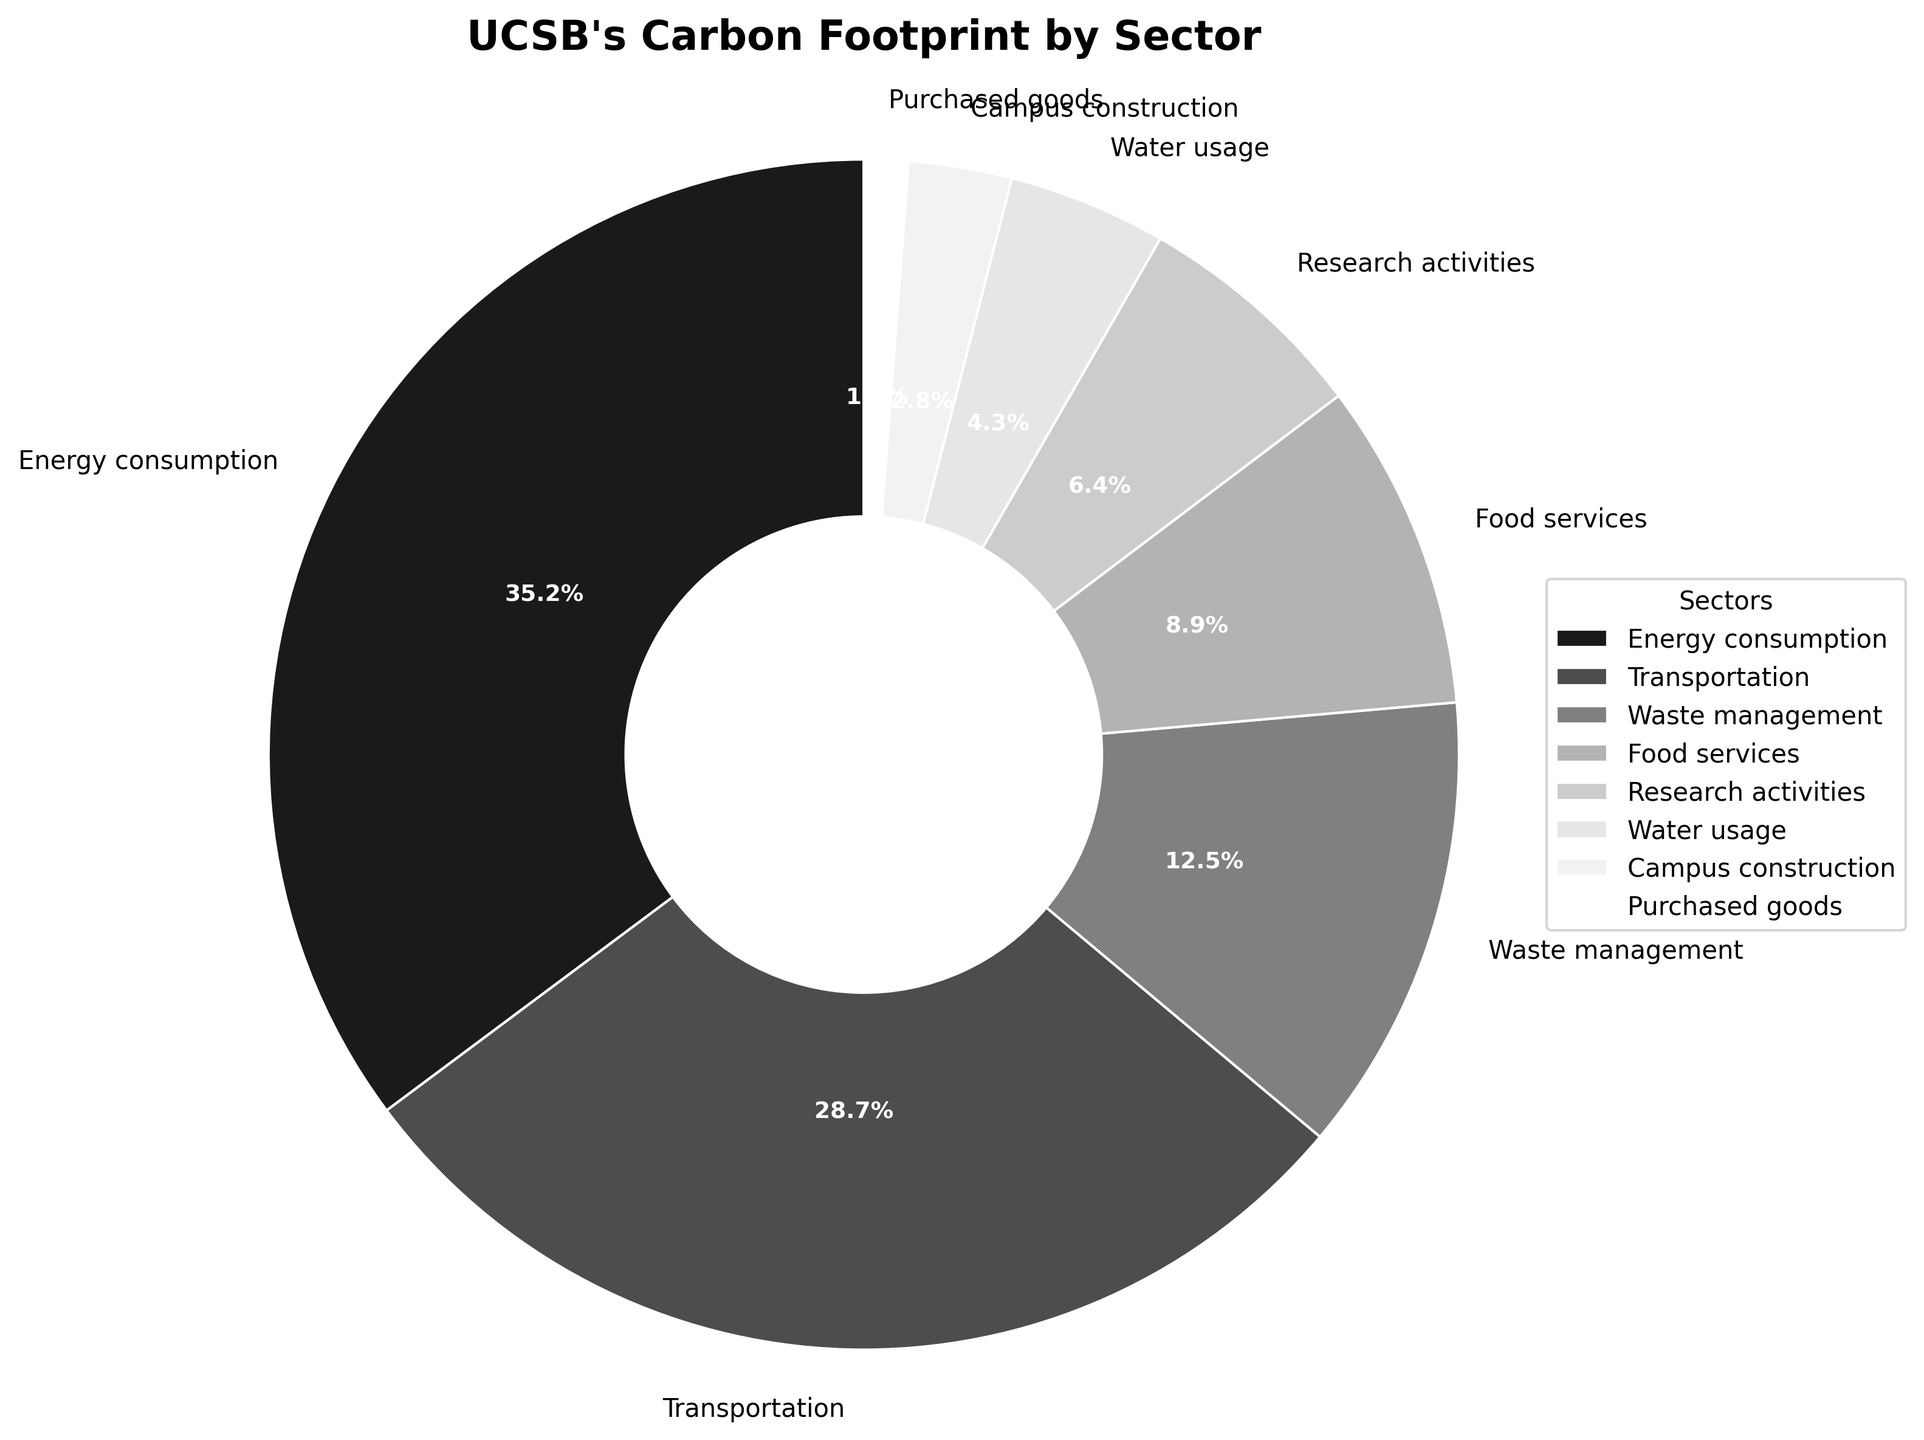Which sector contributes the most to UCSB's carbon footprint? By looking at the pie chart, the sector with the largest percentage slice is identified. Energy consumption has the largest percentage, 35.2%.
Answer: Energy consumption What is the combined carbon footprint percentage of Transportation and Waste Management sectors? Add the percentages of Transportation (28.7%) and Waste Management (12.5%) together. 28.7% + 12.5% = 41.2%
Answer: 41.2% Which sector has the smallest contribution to UCSB's carbon footprint? By examining the pie chart, the sector with the smallest slice is identified. Purchased goods has the smallest percentage, 1.2%.
Answer: Purchased goods How much larger is the Energy Consumption sector compared to the Food Services sector in percentage? Subtract the percentage of Food Services (8.9%) from Energy Consumption (35.2%). 35.2% - 8.9% = 26.3%
Answer: 26.3% Which three sectors have the highest contributions to UCSB's carbon footprint? By identifying the three largest slices in the pie chart. They are Energy Consumption (35.2%), Transportation (28.7%), and Waste Management (12.5%).
Answer: Energy consumption, Transportation, and Waste Management What is the total percentage of UCSB's carbon footprint attributed to Research Activities, Water Usage, and Campus Construction? Add the percentages of Research Activities (6.4%), Water Usage (4.3%), and Campus Construction (2.8%) together. 6.4% + 4.3% + 2.8% = 13.5%
Answer: 13.5% If you combine the contributions of the bottom four sectors, what is their total percentage? Add the percentages of Food Services (8.9%), Research Activities (6.4%), Water Usage (4.3%), and Campus Construction (2.8%) together. 8.9% + 6.4% + 4.3% + 2.8% = 22.4%
Answer: 22.4% How does the carbon footprint of Transportation compare to that of Energy Consumption? By looking at the pie chart, Energy Consumption (35.2%) is larger than Transportation (28.7%).
Answer: Energy Consumption is larger Which sector is represented by the lightest shade in the pie chart? In the grayscale pie chart, the lightest shade corresponds to the slice with the smallest percentage which is Purchased goods (1.2%).
Answer: Purchased goods Is the contribution of Waste Management greater than the combined contributions of Water Usage and Campus Construction? Compare the percentage of Waste Management (12.5%) with the sum of Water Usage (4.3%) and Campus Construction (2.8%). 4.3% + 2.8% = 7.1%, and 12.5% is greater than 7.1%.
Answer: Yes 